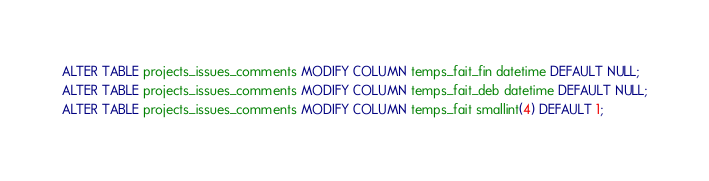Convert code to text. <code><loc_0><loc_0><loc_500><loc_500><_SQL_>ALTER TABLE projects_issues_comments MODIFY COLUMN temps_fait_fin datetime DEFAULT NULL;
ALTER TABLE projects_issues_comments MODIFY COLUMN temps_fait_deb datetime DEFAULT NULL;
ALTER TABLE projects_issues_comments MODIFY COLUMN temps_fait smallint(4) DEFAULT 1;

</code> 